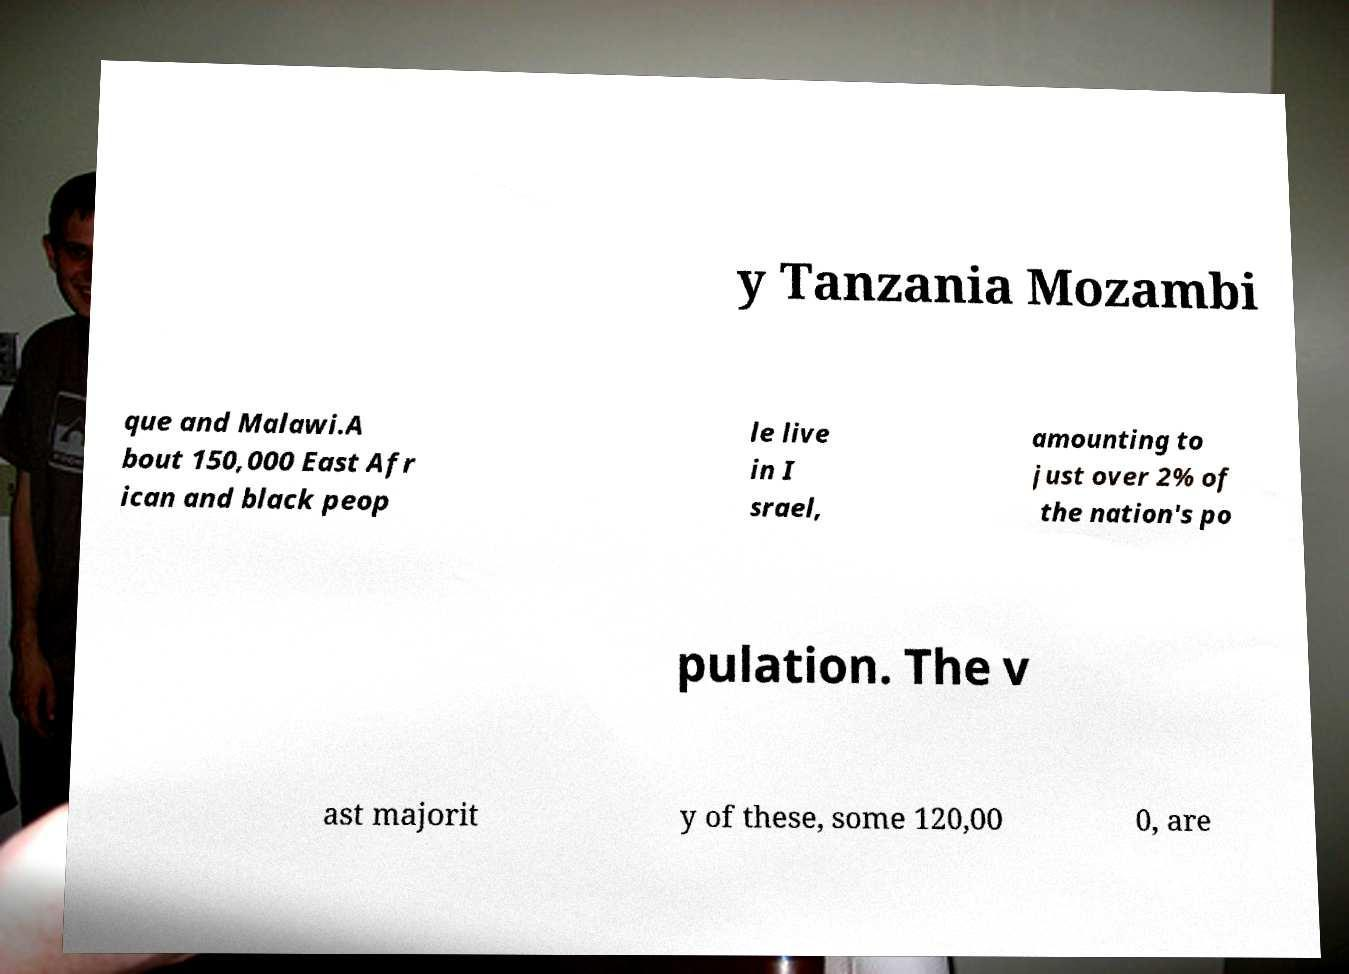Could you extract and type out the text from this image? y Tanzania Mozambi que and Malawi.A bout 150,000 East Afr ican and black peop le live in I srael, amounting to just over 2% of the nation's po pulation. The v ast majorit y of these, some 120,00 0, are 